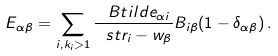Convert formula to latex. <formula><loc_0><loc_0><loc_500><loc_500>E _ { \alpha \beta } = \sum _ { i , k _ { i } > 1 } \frac { \ B t i l d e _ { \alpha i } } { \ s t r _ { i } - w _ { \beta } } B _ { i \beta } ( 1 - \delta _ { \alpha \beta } ) \, .</formula> 